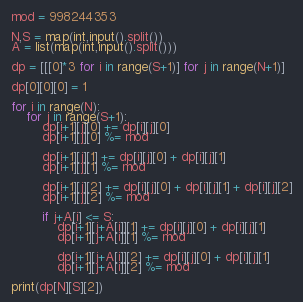<code> <loc_0><loc_0><loc_500><loc_500><_Python_>mod = 998244353

N,S = map(int,input().split())
A = list(map(int,input().split()))

dp = [[[0]*3 for i in range(S+1)] for j in range(N+1)]

dp[0][0][0] = 1

for i in range(N):
    for j in range(S+1):
        dp[i+1][j][0] += dp[i][j][0]
        dp[i+1][j][0] %= mod

        dp[i+1][j][1] += dp[i][j][0] + dp[i][j][1]
        dp[i+1][j][1] %= mod

        dp[i+1][j][2] += dp[i][j][0] + dp[i][j][1] + dp[i][j][2]
        dp[i+1][j][2] %= mod

        if j+A[i] <= S:
            dp[i+1][j+A[i]][1] += dp[i][j][0] + dp[i][j][1]
            dp[i+1][j+A[i]][1] %= mod
        
            dp[i+1][j+A[i]][2] += dp[i][j][0] + dp[i][j][1]
            dp[i+1][j+A[i]][2] %= mod

print(dp[N][S][2])</code> 